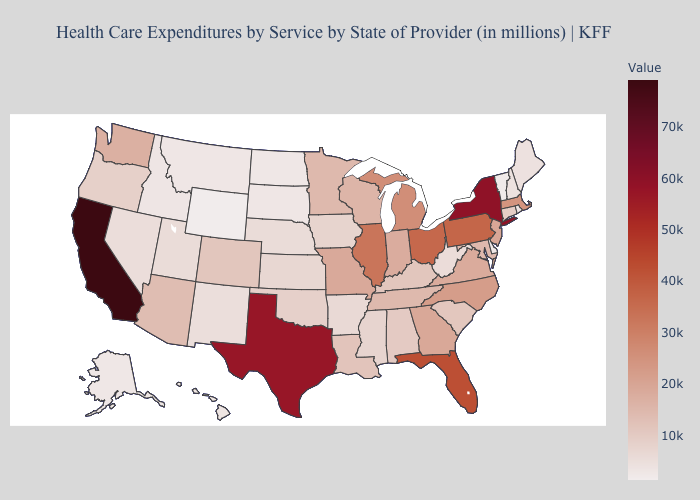Which states have the lowest value in the MidWest?
Concise answer only. North Dakota. Does the map have missing data?
Answer briefly. No. Among the states that border Iowa , does Minnesota have the lowest value?
Answer briefly. No. Which states hav the highest value in the MidWest?
Answer briefly. Ohio. Does Wyoming have the lowest value in the USA?
Short answer required. Yes. Which states have the highest value in the USA?
Write a very short answer. California. Among the states that border Missouri , does Nebraska have the lowest value?
Quick response, please. Yes. 